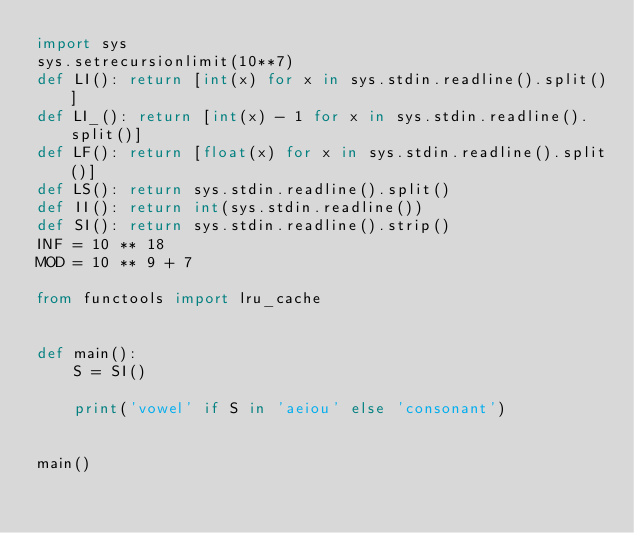<code> <loc_0><loc_0><loc_500><loc_500><_Python_>import sys
sys.setrecursionlimit(10**7)
def LI(): return [int(x) for x in sys.stdin.readline().split()]
def LI_(): return [int(x) - 1 for x in sys.stdin.readline().split()]
def LF(): return [float(x) for x in sys.stdin.readline().split()]
def LS(): return sys.stdin.readline().split()
def II(): return int(sys.stdin.readline())
def SI(): return sys.stdin.readline().strip()
INF = 10 ** 18
MOD = 10 ** 9 + 7

from functools import lru_cache


def main(): 
    S = SI()

    print('vowel' if S in 'aeiou' else 'consonant')


main()</code> 